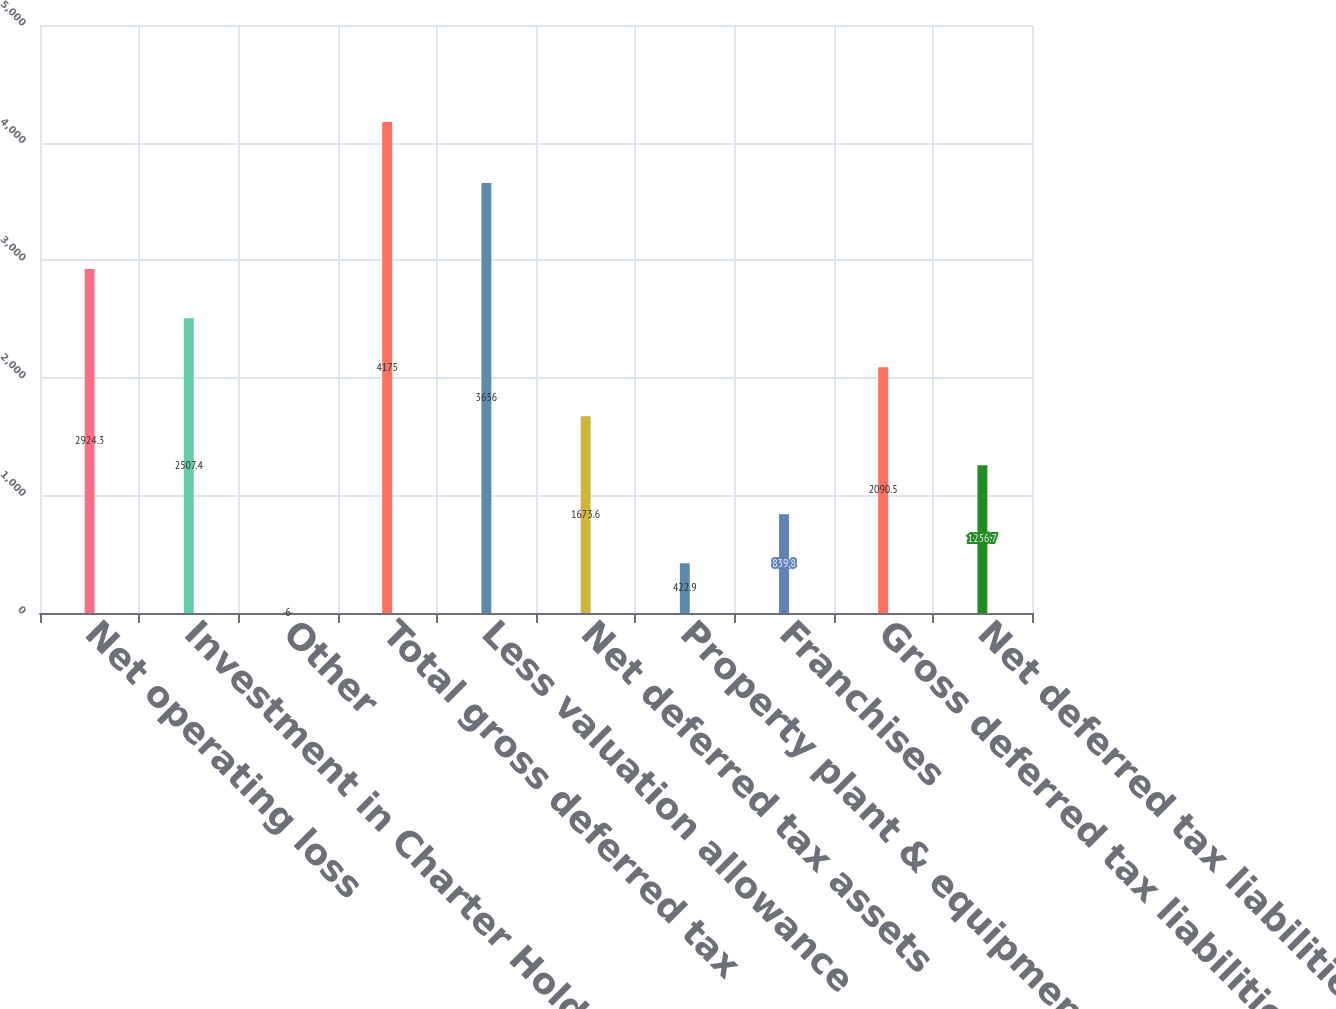Convert chart. <chart><loc_0><loc_0><loc_500><loc_500><bar_chart><fcel>Net operating loss<fcel>Investment in Charter Holdco<fcel>Other<fcel>Total gross deferred tax<fcel>Less valuation allowance<fcel>Net deferred tax assets<fcel>Property plant & equipment<fcel>Franchises<fcel>Gross deferred tax liabilities<fcel>Net deferred tax liabilities<nl><fcel>2924.3<fcel>2507.4<fcel>6<fcel>4175<fcel>3656<fcel>1673.6<fcel>422.9<fcel>839.8<fcel>2090.5<fcel>1256.7<nl></chart> 